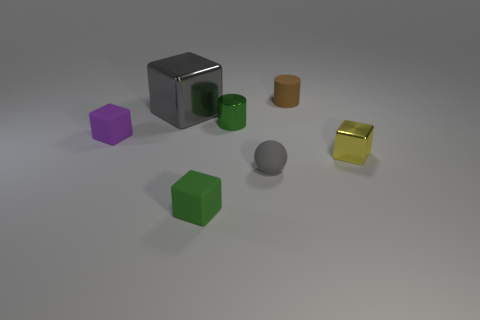Subtract all large gray metallic blocks. How many blocks are left? 3 Subtract all purple cubes. How many cubes are left? 3 Add 3 red shiny blocks. How many objects exist? 10 Subtract all spheres. How many objects are left? 6 Add 6 big metal things. How many big metal things are left? 7 Add 2 tiny red shiny balls. How many tiny red shiny balls exist? 2 Subtract 1 gray cubes. How many objects are left? 6 Subtract 1 spheres. How many spheres are left? 0 Subtract all green blocks. Subtract all green cylinders. How many blocks are left? 3 Subtract all metallic cubes. Subtract all tiny green shiny things. How many objects are left? 4 